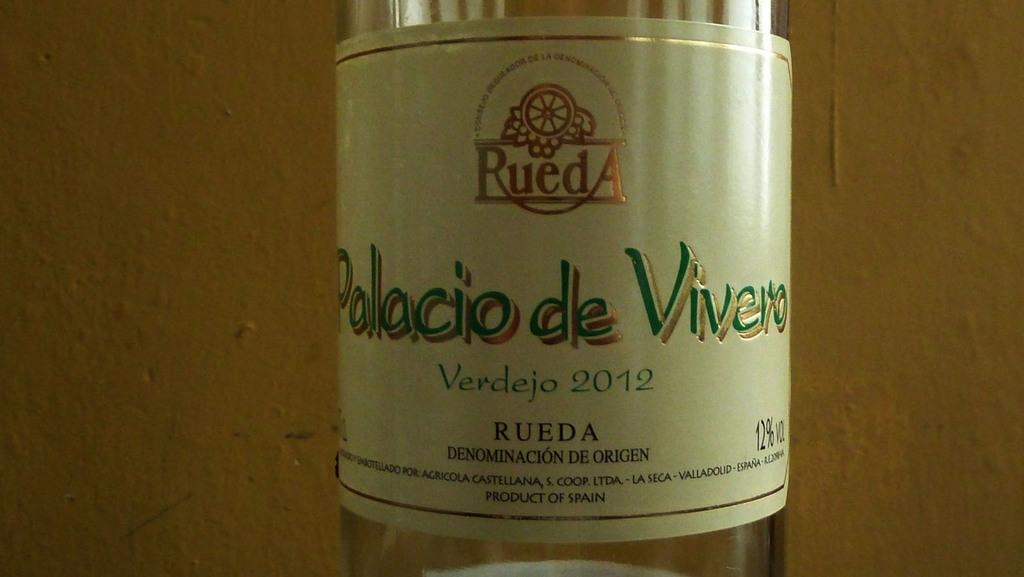Provide a one-sentence caption for the provided image. A clear bottle of Palacio de Vivero is from 2012. 